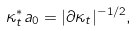Convert formula to latex. <formula><loc_0><loc_0><loc_500><loc_500>\kappa _ { t } ^ { * } a _ { 0 } = | \partial \kappa _ { t } | ^ { - 1 / 2 } ,</formula> 